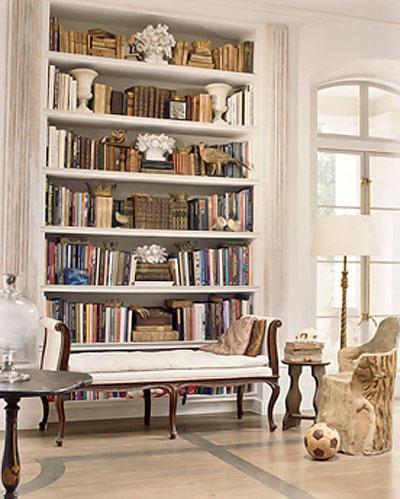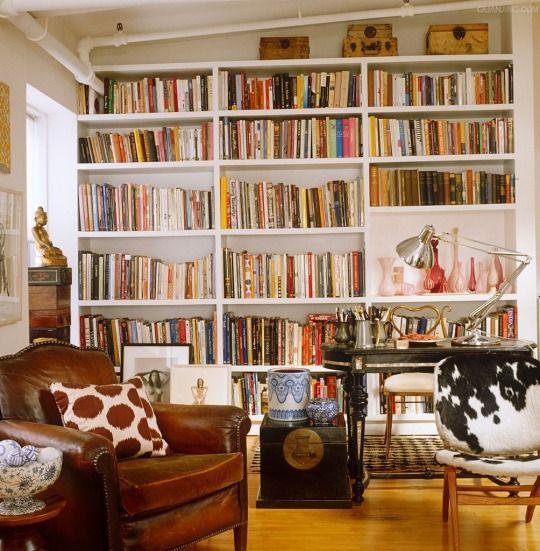The first image is the image on the left, the second image is the image on the right. For the images displayed, is the sentence "In one image, small shelves attached directly to the wall wrap around a corner." factually correct? Answer yes or no. No. The first image is the image on the left, the second image is the image on the right. Analyze the images presented: Is the assertion "An image shows a hanging corner shelf style without back or sides." valid? Answer yes or no. No. 